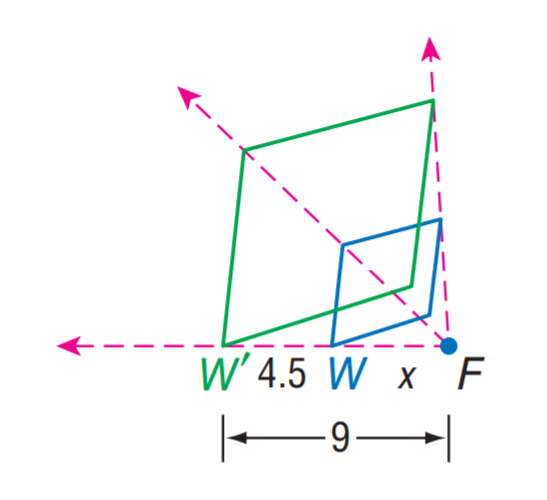Question: Find the scale factor from W to W'.
Choices:
A. 2
B. 4.5
C. 9
D. 18
Answer with the letter. Answer: A 